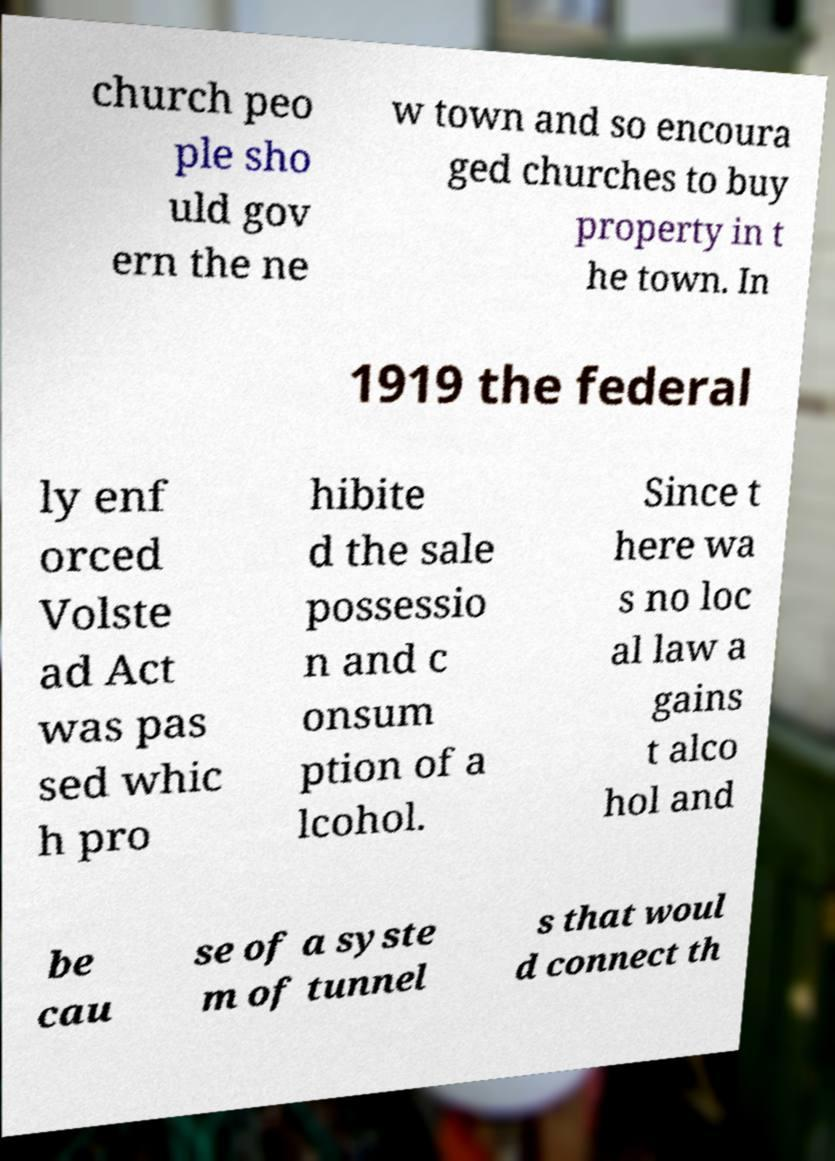Can you accurately transcribe the text from the provided image for me? church peo ple sho uld gov ern the ne w town and so encoura ged churches to buy property in t he town. In 1919 the federal ly enf orced Volste ad Act was pas sed whic h pro hibite d the sale possessio n and c onsum ption of a lcohol. Since t here wa s no loc al law a gains t alco hol and be cau se of a syste m of tunnel s that woul d connect th 